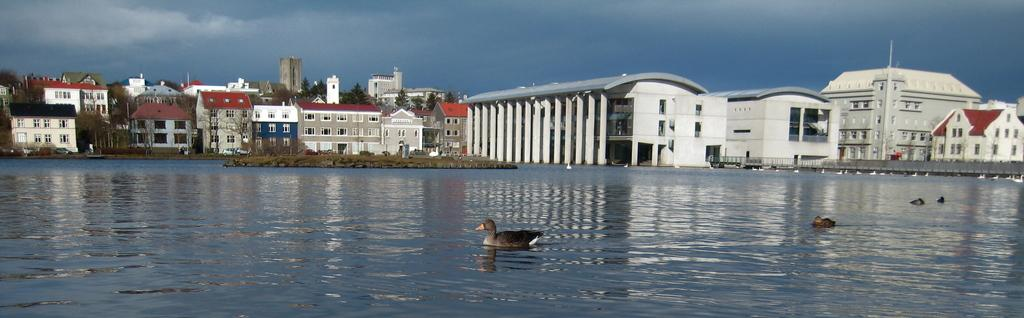What animals are in the foreground of the picture? There are birds in the foreground of the picture. Where are the birds located? The birds are on the water. What can be seen in the background of the image? There are buildings and trees in the background of the image. What is visible in the sky? There are clouds in the sky. What type of cracker is being used to turn the page in the image? There is no cracker or page present in the image; it features birds on the water with buildings and trees in the background. 